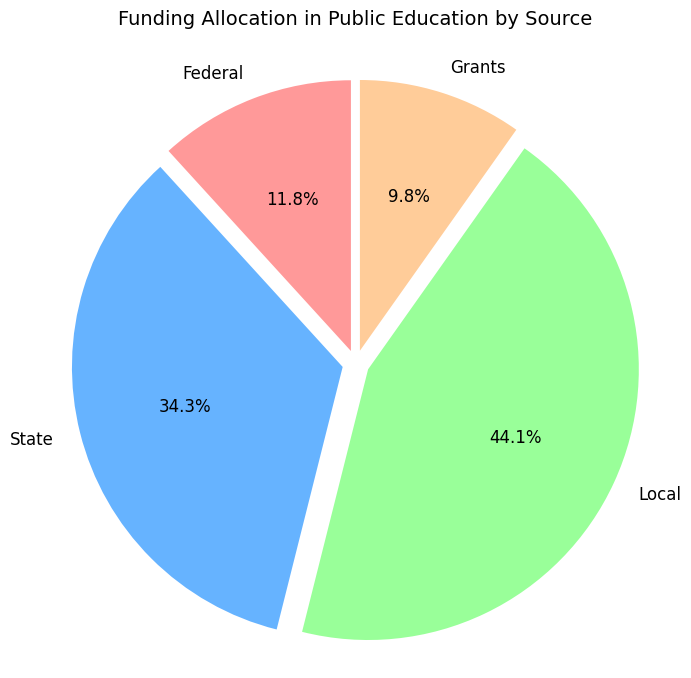How much funding comes from federal sources? The pie chart slices show different funding sources. The Federal slice shows the amount as part of the chart.
Answer: $1,200,000 Which funding source provides the highest amount? Among the slices of the pie chart (Federal, State, Local, and Grants), the Local slice appears to have the largest portion.
Answer: Local How does state funding compare to local funding? The State slice is smaller than the Local slice in the pie chart, indicating that state funding is less than local funding.
Answer: State funding is less than local funding What is the difference between state funding and federal funding? The pie chart shows state funding as $3,500,000 and federal funding as $1,200,000. The difference is $3,500,000 - $1,200,000 = $2,300,000.
Answer: $2,300,000 Which two funding sources together make up more than half of the total funding? In the pie chart, Local (45%) and State (35%) together make up 80%, which is more than half the total funding.
Answer: Local and State What percentage of the total funding comes from grants? The Grants slice shows the portion of the funding. It has an automated percentage label of 10%.
Answer: 10% If local funding were reduced by $1,000,000, what would the new total amount from local funding be? Local funding is currently $4,500,000. Reducing it by $1,000,000 would make it $4,500,000 - $1,000,000 = $3,500,000.
Answer: $3,500,000 What is the combined funding from federal and grants? From the pie chart, Federal funding is $1,200,000, and Grants are $1,000,000. Combined, they amount to $1,200,000 + $1,000,000 = $2,200,000.
Answer: $2,200,000 